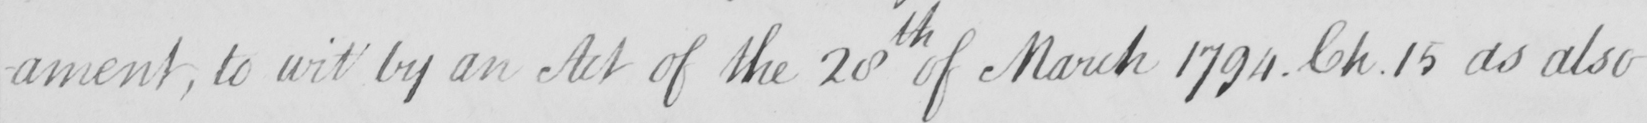Can you read and transcribe this handwriting? -ament , to wit by an Act of the 20th of March 1794 Ch.15 as also 